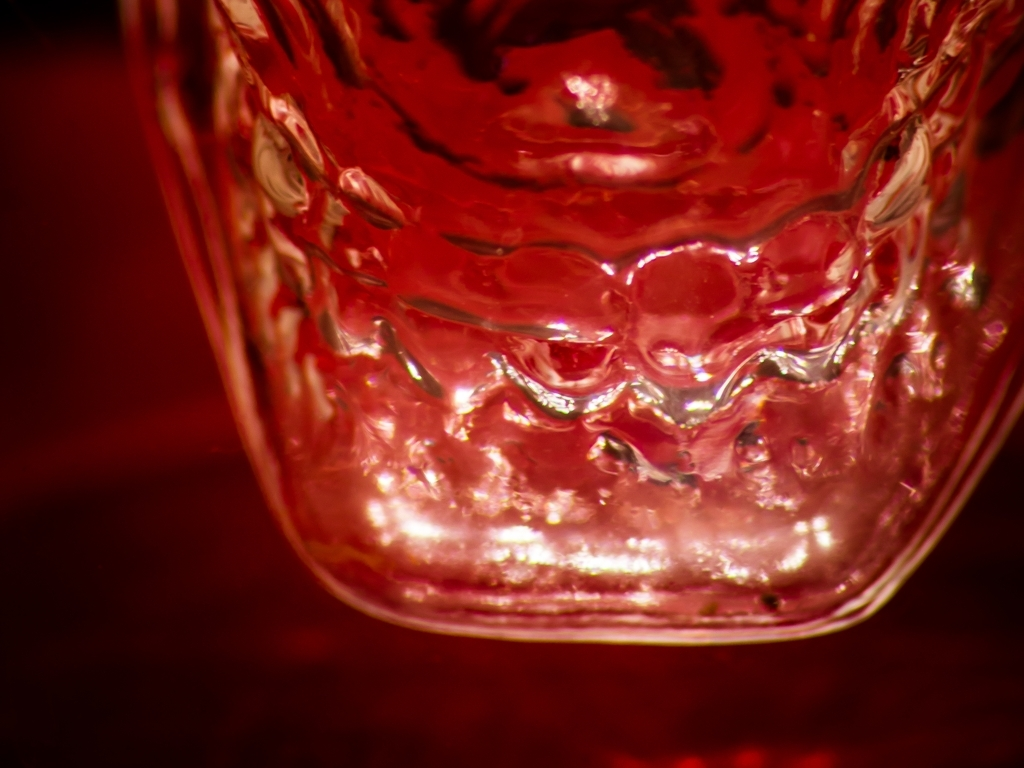What type of lighting has been used to capture this image? The red hues and soft shadows suggest that the image was taken under warm, diffuse lighting, possibly to accentuate the intricate details and texture of the object. 